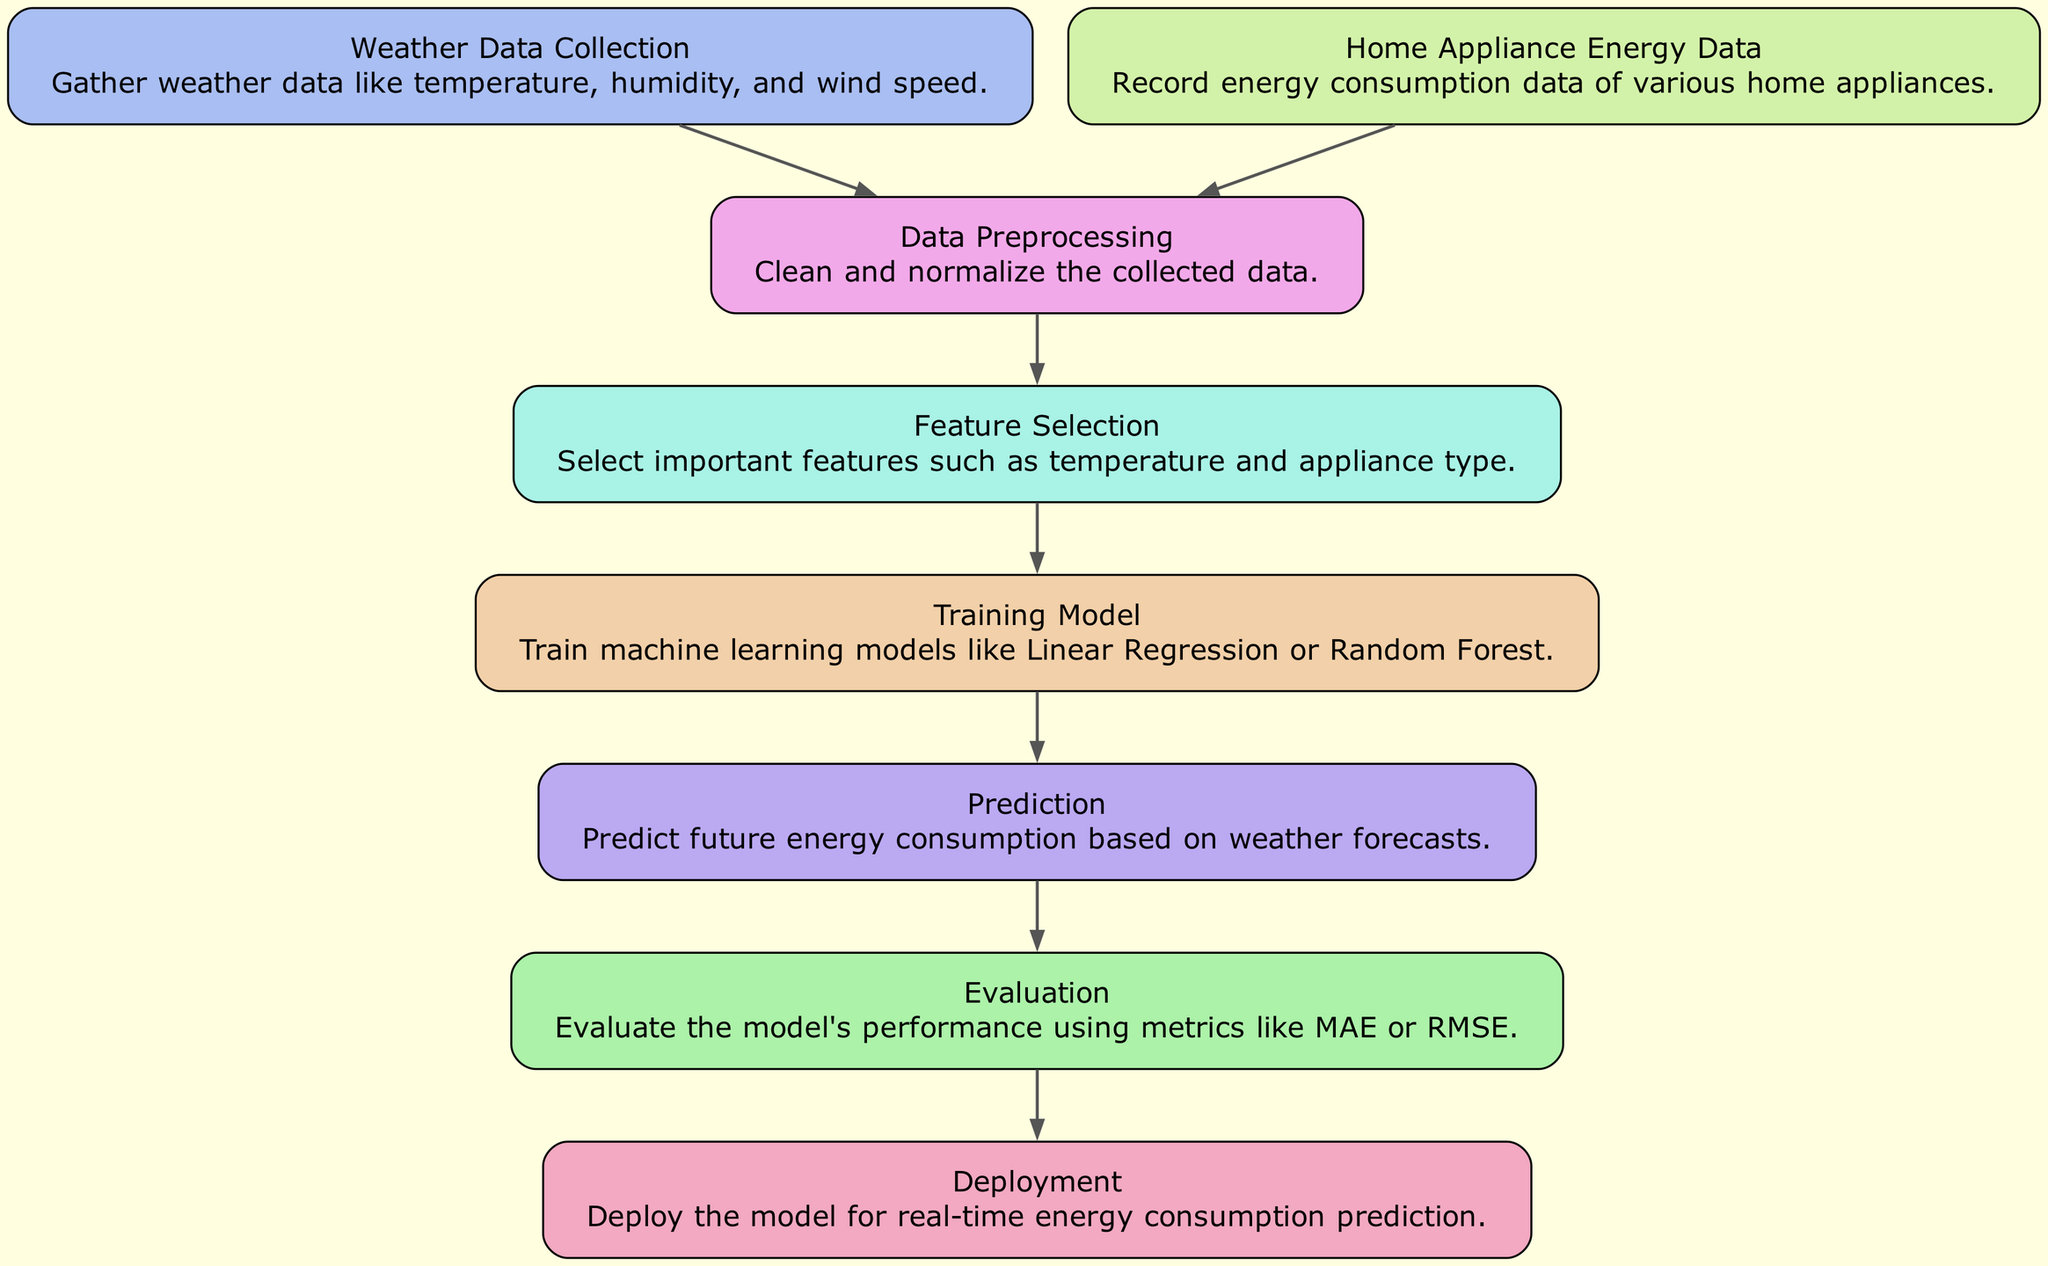What is the first step in the diagram? The first step shown in the diagram is the "Weather Data Collection" node, which gathers data like temperature, humidity, and wind speed.
Answer: Weather Data Collection How many nodes are there in the diagram? By counting the nodes represented in the diagram, we can see there are a total of eight distinct nodes related to the process of energy consumption prediction.
Answer: Eight What type of model is trained in this diagram? The diagram mentions that machine learning models such as Linear Regression or Random Forest are trained during the "Training Model" step.
Answer: Linear Regression or Random Forest Which two nodes are connected directly before "Prediction"? The "Training Model" node connects directly to the "Prediction" node, indicating that predictions are made after training the model.
Answer: Training Model and Prediction What metric is used for evaluation? The evaluation step mentions that metrics like Mean Absolute Error (MAE) or Root Mean Square Error (RMSE) are used to evaluate the model's performance.
Answer: MAE or RMSE What would happen after Evaluation in the diagram? Following the "Evaluation" node, the process leads to the "Deployment" node where the model is deployed for real-time energy consumption prediction.
Answer: Deployment Which node collects data from home appliances? The "Home Appliance Energy Data" node is responsible for recording the energy consumption data of various home appliances.
Answer: Home Appliance Energy Data What is the main purpose of the diagram? The diagram aims to depict the process of predicting energy consumption for home appliances based on collected weather data.
Answer: Predicting energy consumption What is the relationship between "Data Preprocessing" and "Feature Selection"? "Data Preprocessing" is a prerequisite for "Feature Selection," meaning that data must be cleaned and normalized before selecting important features.
Answer: Preceding relationship 